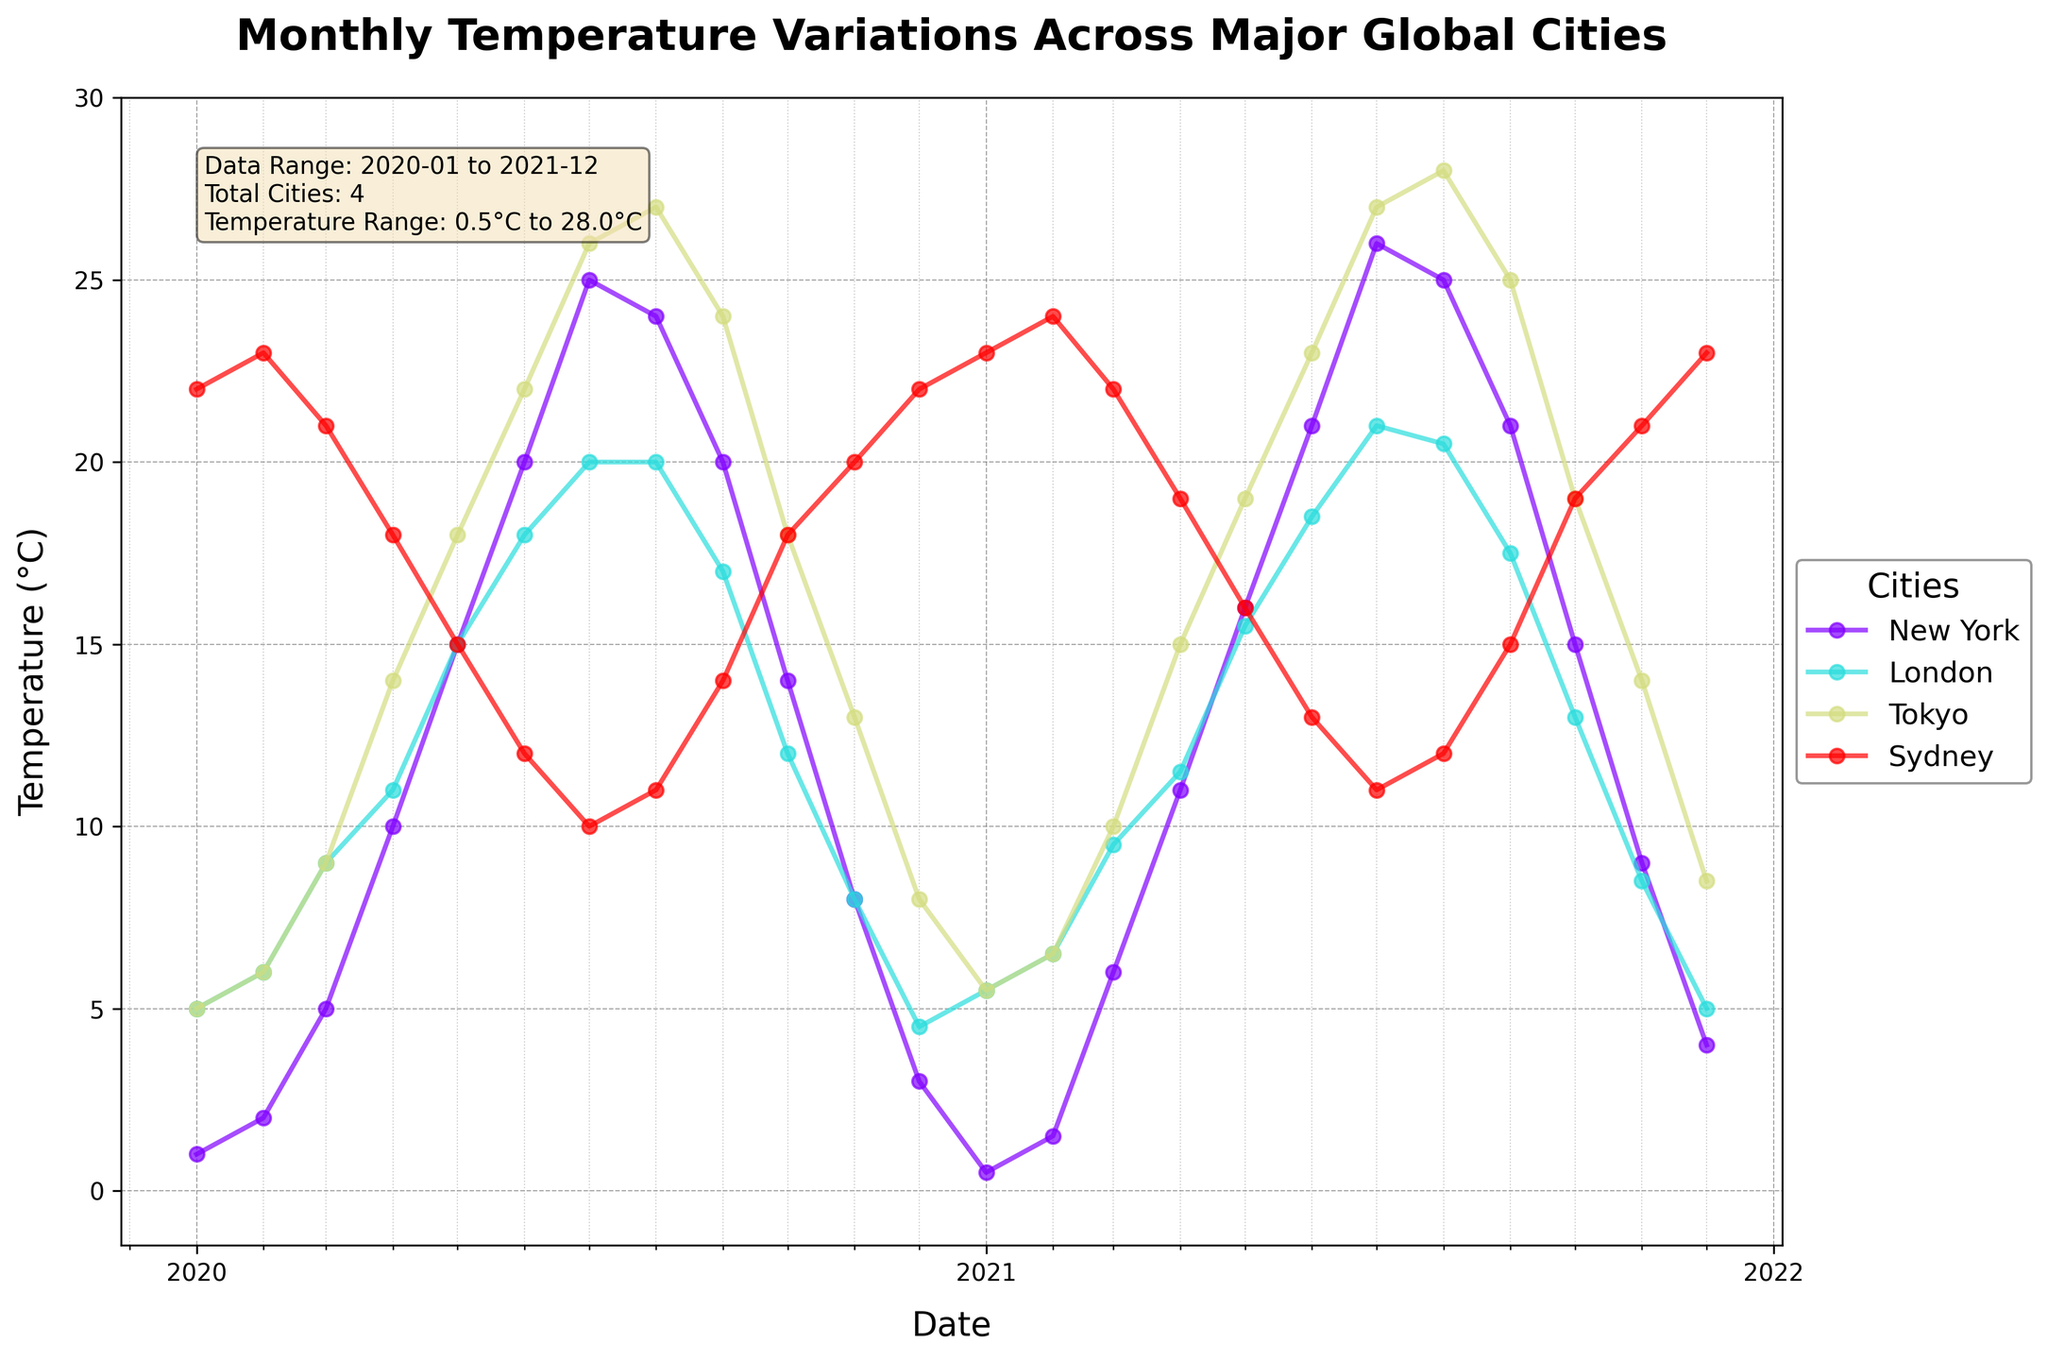What is the title of the plot? The title is displayed at the top of the plot. It describes what the plot is about.
Answer: Monthly Temperature Variations Across Major Global Cities Which city shows the highest recorded temperature in the dataset? Identify the peak point in the time series with the highest temperature for all cities.
Answer: Tokyo What are the temperature ranges recorded for New York and Sydney during the years 2020-2021? Find the minimum and maximum temperatures for New York and Sydney by examining the temperature values for each month in both years.
Answer: New York: 0.5°C to 26.0°C, Sydney: 10.0°C to 24.0°C How does the temperature trend in London compare with that in Tokyo over the years shown? Look at the overall trend of temperature changes across months and years for both London and Tokyo.
Answer: Tokyo shows higher peaks in summer and more variation, while London has more moderate temperatures year-round Which city had the most stable (least variable) temperature throughout the two years? Assess the temperature plots for each city and determine which city's temperature line has the least fluctuation over the given period.
Answer: Sydney What is the general pattern observed in temperature variations in New York? Observe the cyclical pattern of temperature changes across months and identify the seasons' effects.
Answer: Warmer during June to August and colder from December to February By what degree does Tokyo's highest temperature differ from London's highest temperature? Identify the highest temperature points for Tokyo and London, then calculate the difference between these values.
Answer: 8°C (Tokyo highest: 28°C, London highest: 20°C) During which month does New York typically start warming up in the year? Check the time series data for New York to identify the month where an upward trend in temperature begins.
Answer: March What specific time period is represented in this plot? Review data summary box on the plot for start and end of data representation.
Answer: January 2020 to December 2021 Compare the temperature range for Tokyo in January and July of both years. Examine the temperatures for Tokyo in January and July respectively for both years, then calculate the range for each month.
Answer: January: 5.0°C to 5.5°C, July: 26°C to 27°C 